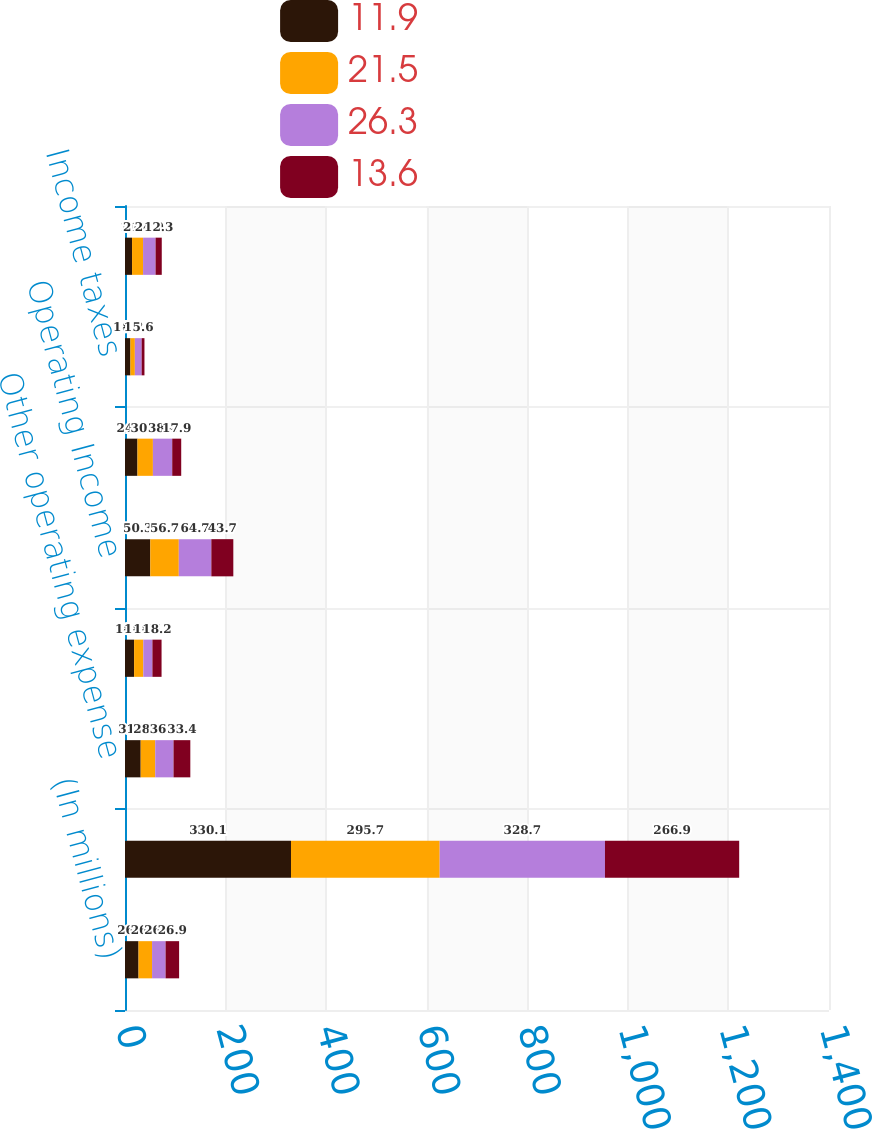<chart> <loc_0><loc_0><loc_500><loc_500><stacked_bar_chart><ecel><fcel>(In millions)<fcel>Revenues<fcel>Other operating expense<fcel>Provision for depreciation<fcel>Operating Income<fcel>Income before income taxes<fcel>Income taxes<fcel>Net Income<nl><fcel>11.9<fcel>26.9<fcel>330.1<fcel>31.2<fcel>18.1<fcel>50.3<fcel>24.8<fcel>10.8<fcel>14<nl><fcel>21.5<fcel>26.9<fcel>295.7<fcel>28.9<fcel>18.3<fcel>56.7<fcel>30.7<fcel>8.8<fcel>21.9<nl><fcel>26.3<fcel>26.9<fcel>328.7<fcel>36.4<fcel>18.1<fcel>64.7<fcel>38.4<fcel>13.5<fcel>24.9<nl><fcel>13.6<fcel>26.9<fcel>266.9<fcel>33.4<fcel>18.2<fcel>43.7<fcel>17.9<fcel>5.6<fcel>12.3<nl></chart> 